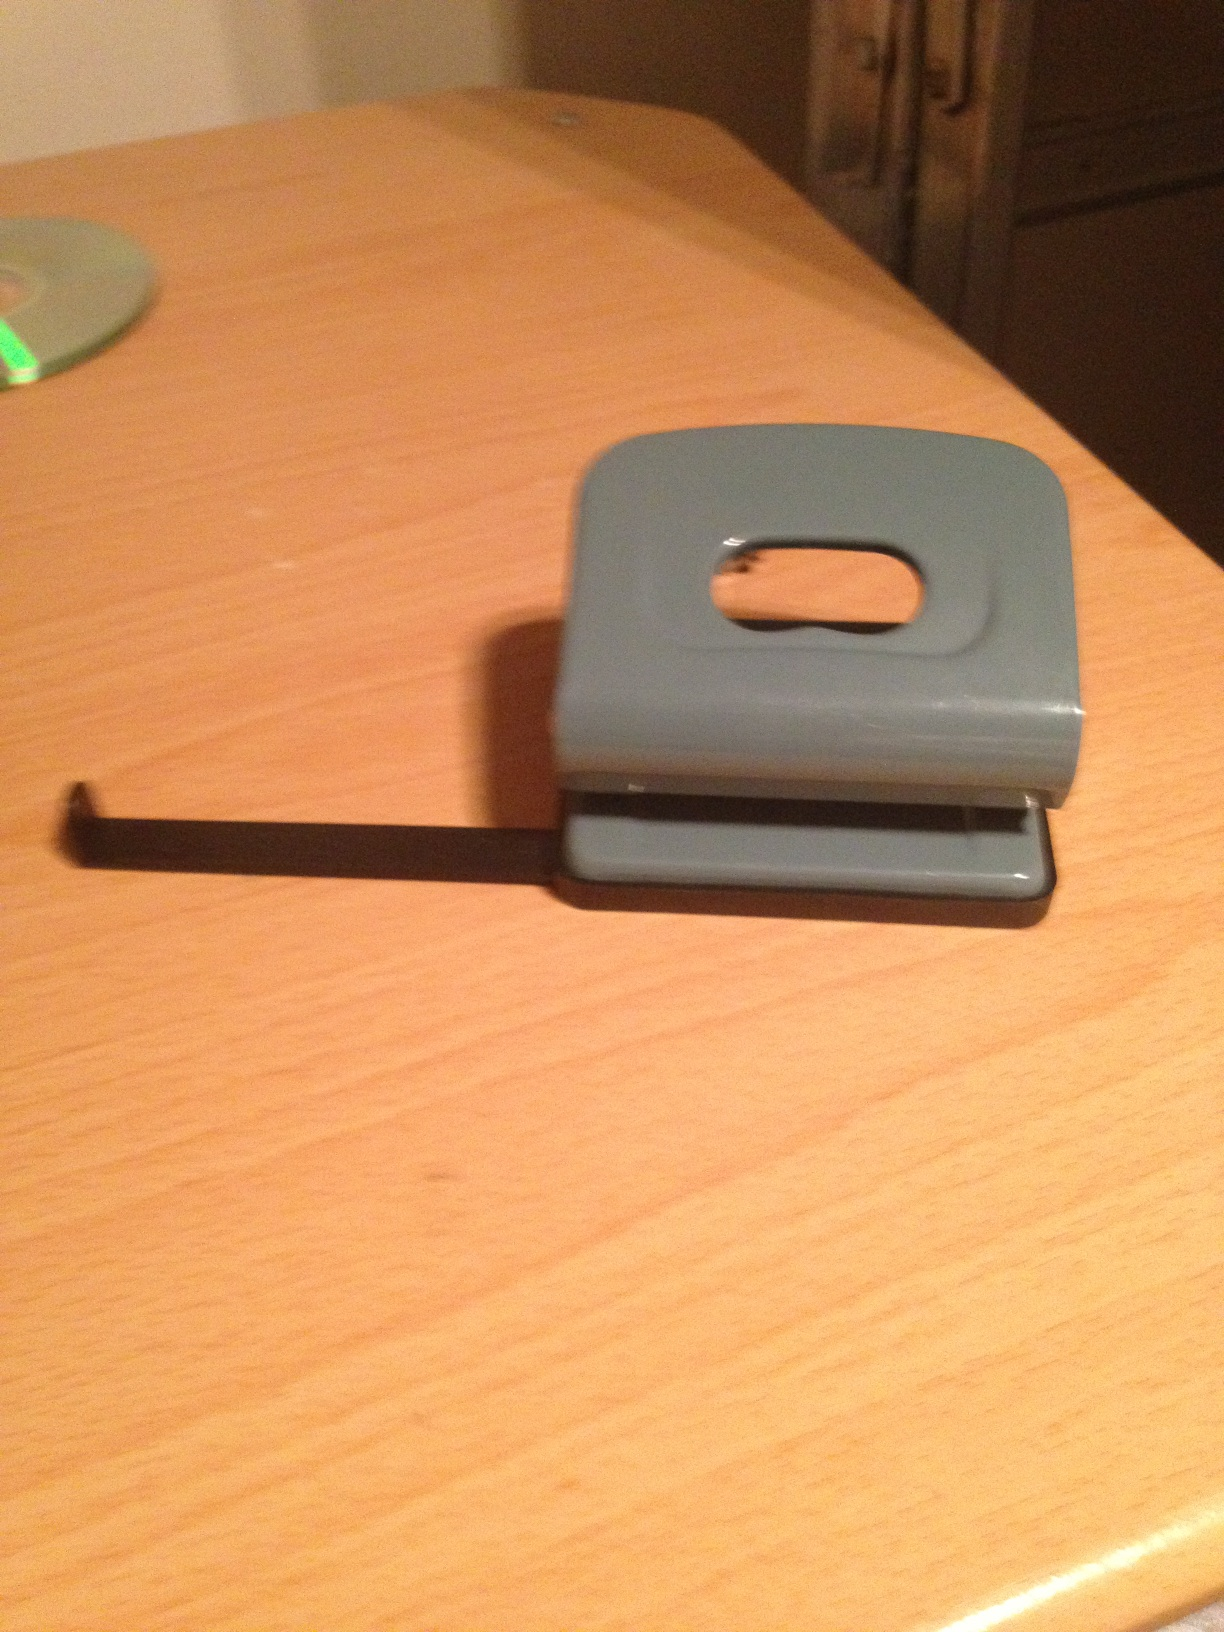What is this? This is an image of a hole punch. It is a device typically used to create holes in sheets of paper, often for the purpose of collecting and organizing the sheets in binders or folders. 